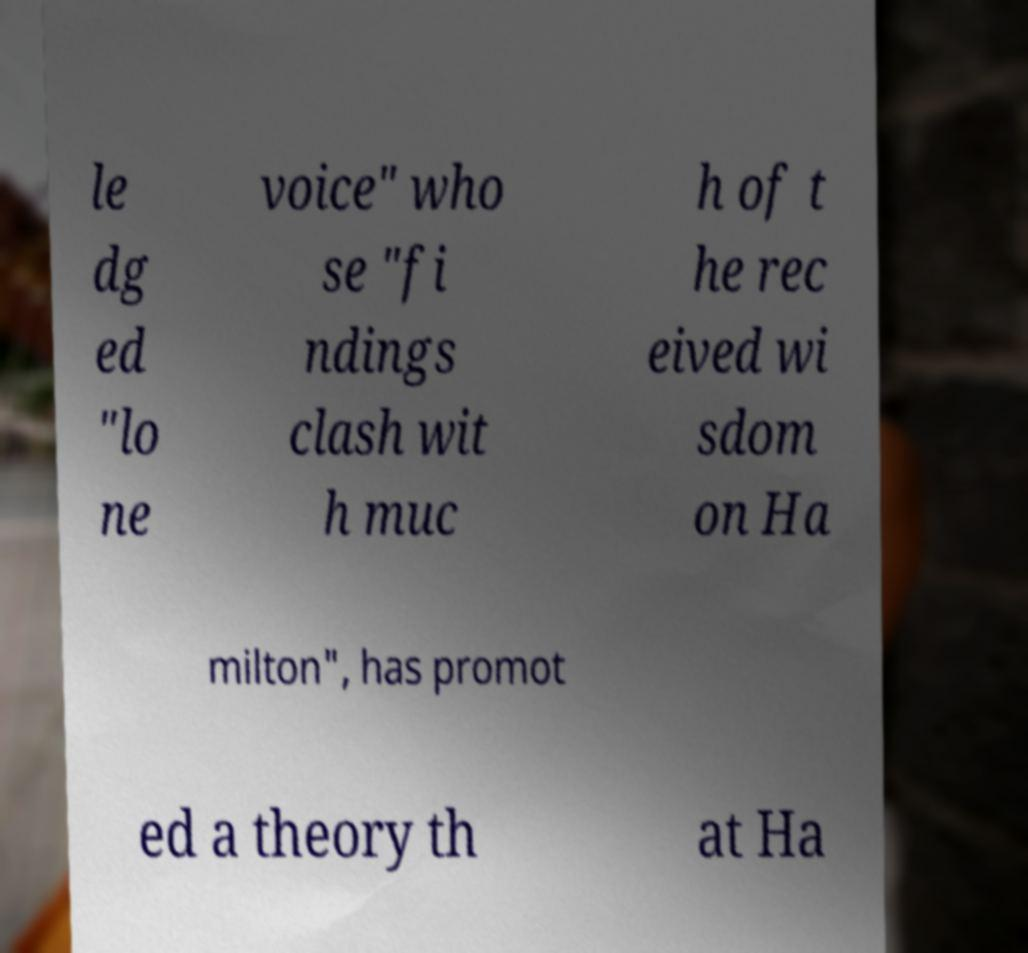There's text embedded in this image that I need extracted. Can you transcribe it verbatim? le dg ed "lo ne voice" who se "fi ndings clash wit h muc h of t he rec eived wi sdom on Ha milton", has promot ed a theory th at Ha 